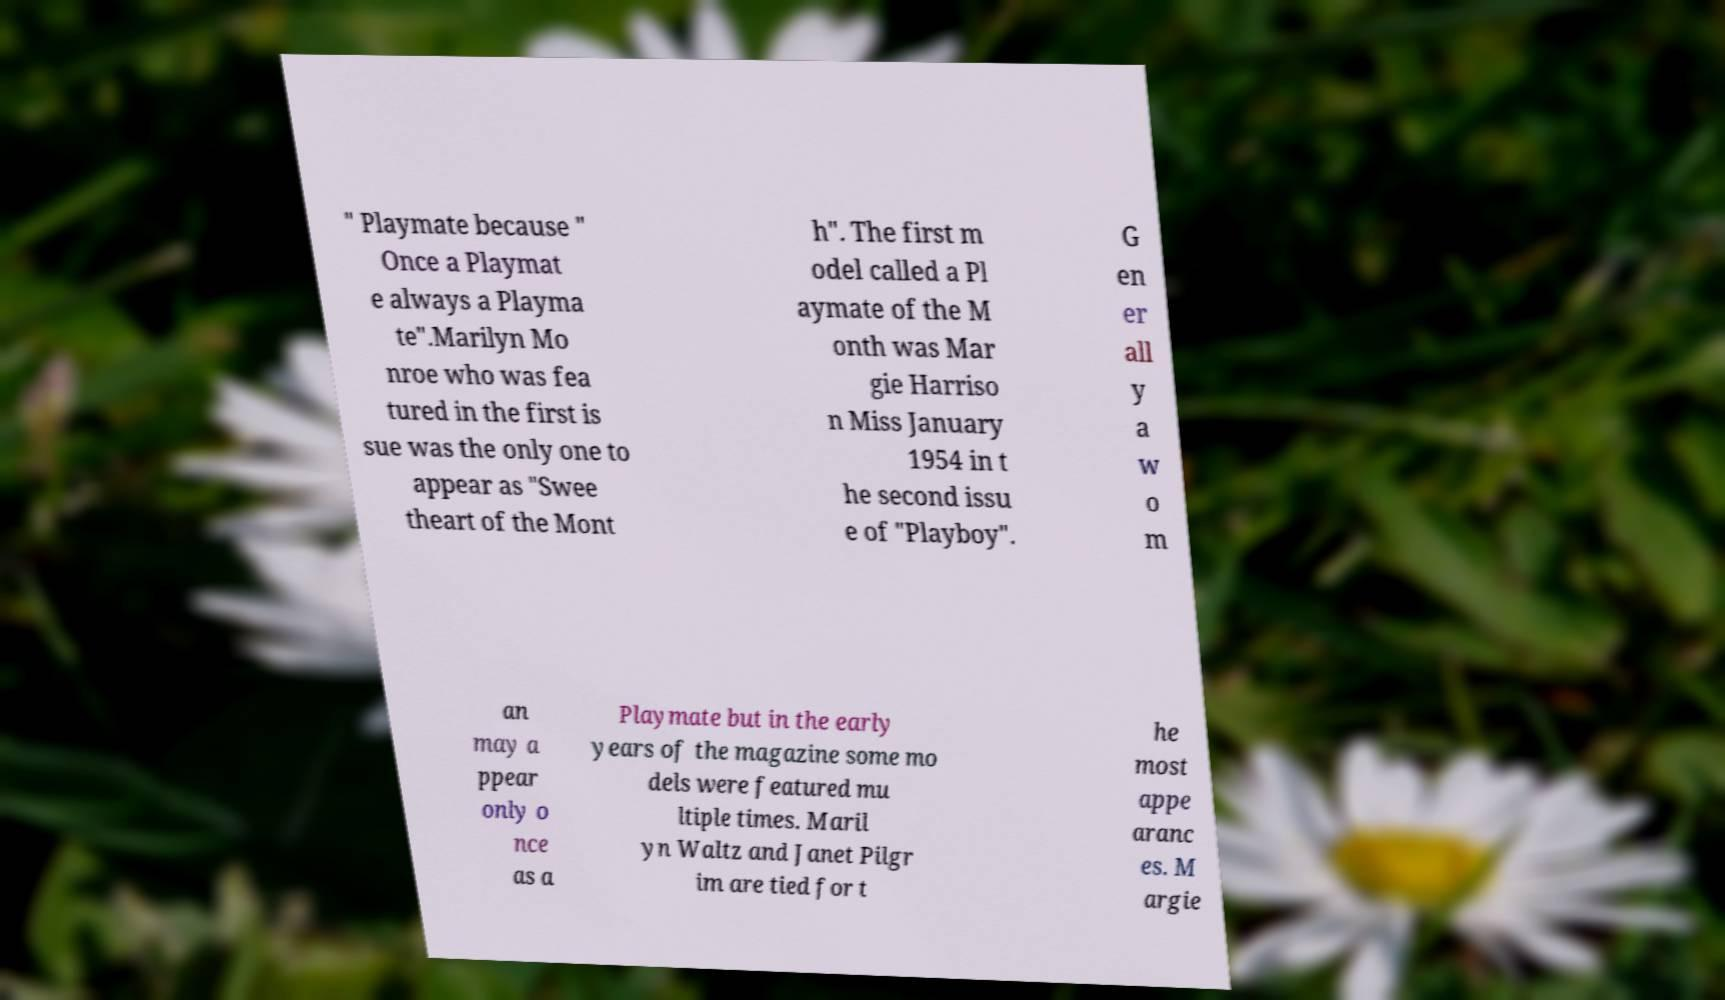Can you accurately transcribe the text from the provided image for me? " Playmate because " Once a Playmat e always a Playma te".Marilyn Mo nroe who was fea tured in the first is sue was the only one to appear as "Swee theart of the Mont h". The first m odel called a Pl aymate of the M onth was Mar gie Harriso n Miss January 1954 in t he second issu e of "Playboy". G en er all y a w o m an may a ppear only o nce as a Playmate but in the early years of the magazine some mo dels were featured mu ltiple times. Maril yn Waltz and Janet Pilgr im are tied for t he most appe aranc es. M argie 